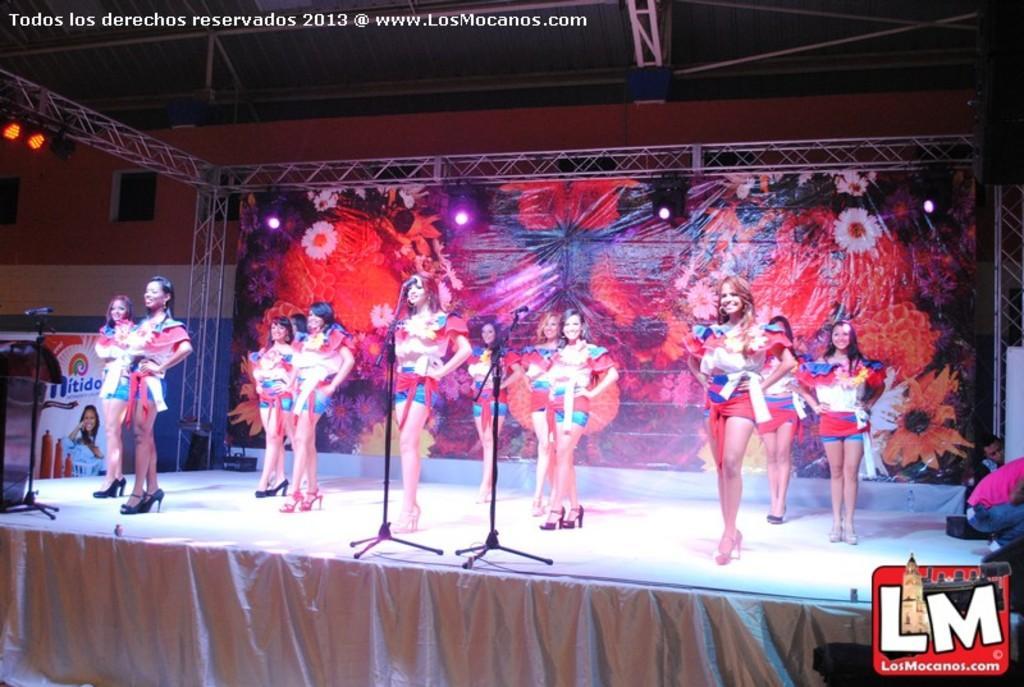In one or two sentences, can you explain what this image depicts? In this image we can see a group of people are standing on the stage, there is a microphone, at back there is the banner, there are the lights. 